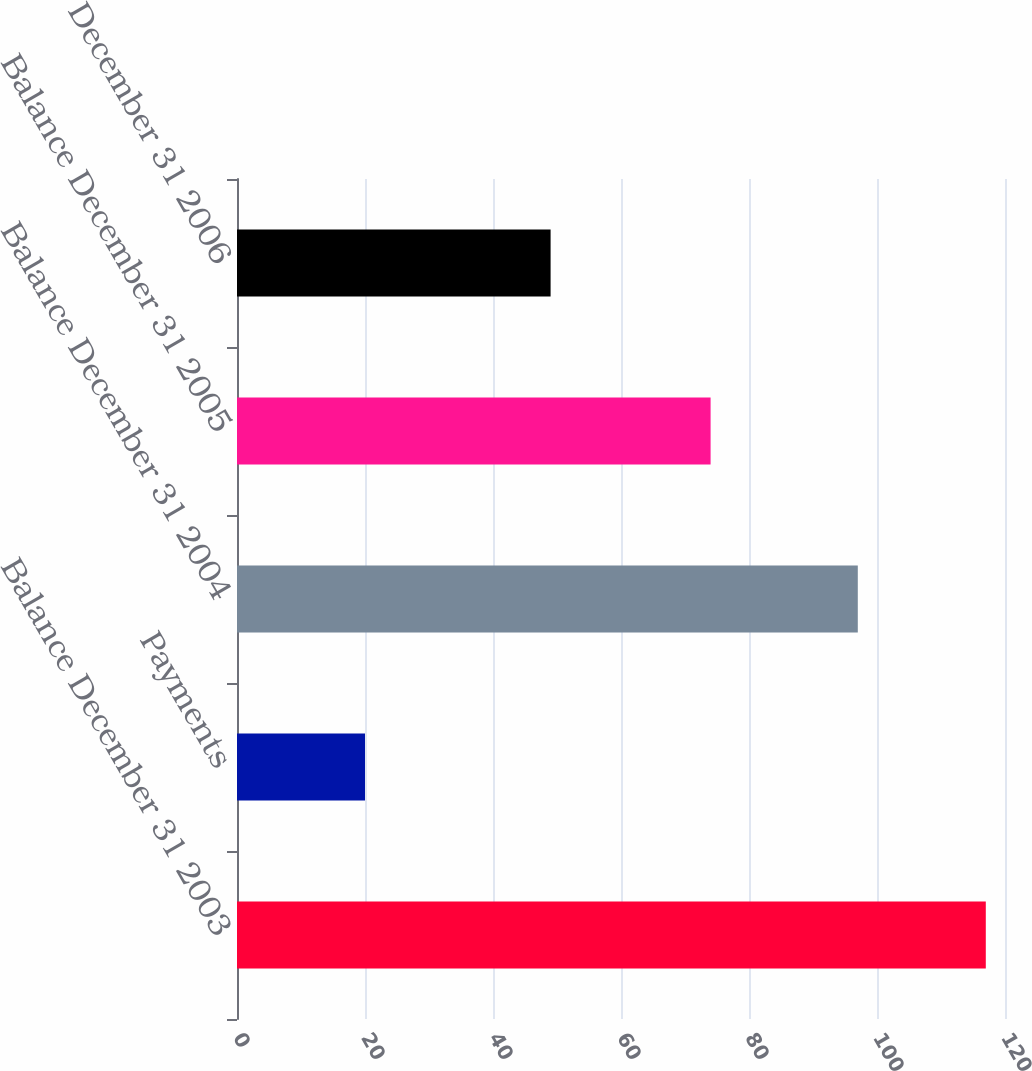<chart> <loc_0><loc_0><loc_500><loc_500><bar_chart><fcel>Balance December 31 2003<fcel>Payments<fcel>Balance December 31 2004<fcel>Balance December 31 2005<fcel>Balance December 31 2006<nl><fcel>117<fcel>20<fcel>97<fcel>74<fcel>49<nl></chart> 